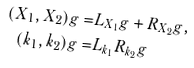Convert formula to latex. <formula><loc_0><loc_0><loc_500><loc_500>( X _ { 1 } , X _ { 2 } ) g = & L _ { X _ { 1 } } g + R _ { X _ { 2 } } g , \\ ( k _ { 1 } , k _ { 2 } ) g = & L _ { k _ { 1 } } R _ { k _ { 2 } } g</formula> 